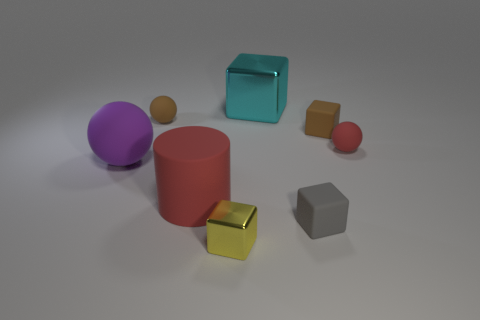Add 2 matte cylinders. How many objects exist? 10 Subtract all cylinders. How many objects are left? 7 Subtract 0 blue cubes. How many objects are left? 8 Subtract all big red metallic balls. Subtract all brown blocks. How many objects are left? 7 Add 2 brown balls. How many brown balls are left? 3 Add 7 tiny red metal cubes. How many tiny red metal cubes exist? 7 